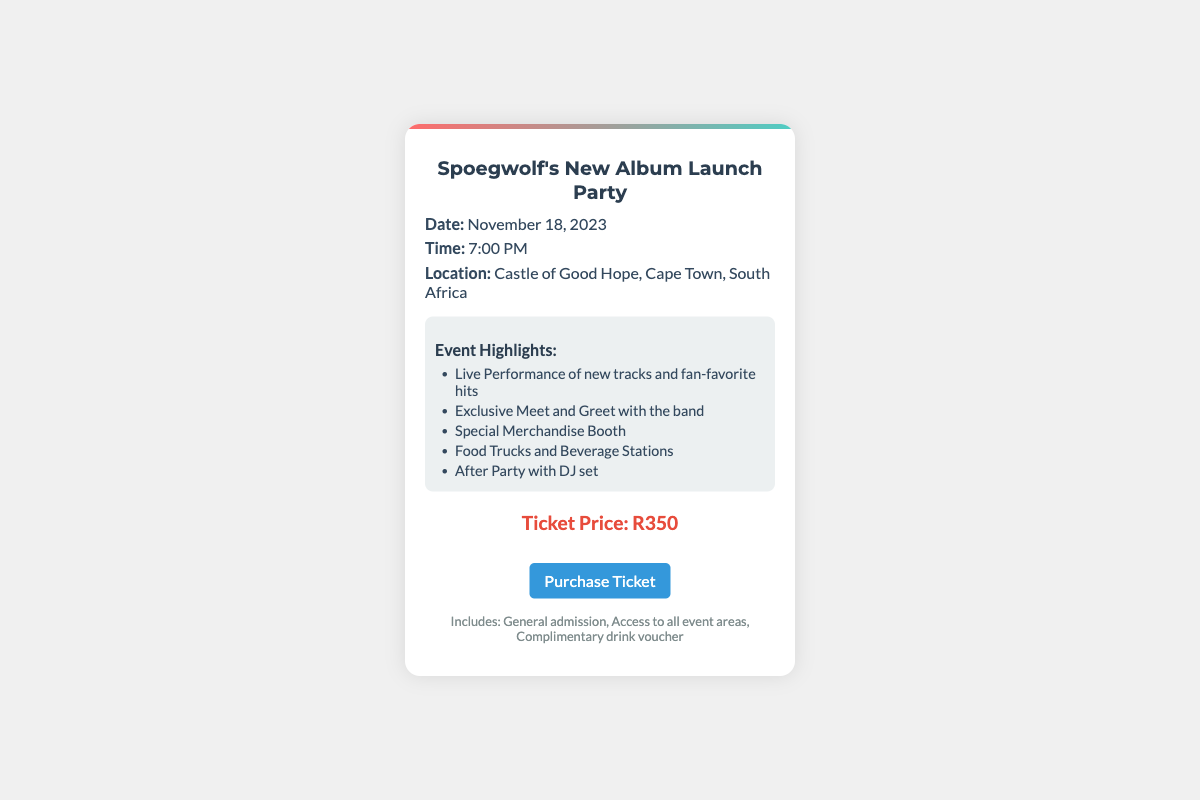what is the date of the event? The date is explicitly mentioned in the document.
Answer: November 18, 2023 what time does the event start? The event time is provided in the details section of the document.
Answer: 7:00 PM where is the event taking place? The location is clearly stated in the event details.
Answer: Castle of Good Hope, Cape Town, South Africa how much is the ticket price? The price for admission is listed prominently in the document.
Answer: R350 what is one of the event highlights? The document lists several highlights; one example is sufficient.
Answer: Live Performance of new tracks and fan-favorite hits what do attendees receive with their ticket? The document specifies what is included with the ticket purchase in the footer.
Answer: General admission, Access to all event areas, Complimentary drink voucher which event feature involves interaction with the band? The highlights section outlines various activities at the event.
Answer: Exclusive Meet and Greet with the band which kind of post-event activity is mentioned? The document provides information on what follows after the main event.
Answer: After Party with DJ set what types of food services will be available? The highlights mention food-related features available at the event.
Answer: Food Trucks and Beverage Stations 